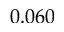<formula> <loc_0><loc_0><loc_500><loc_500>0 . 0 6 0</formula> 